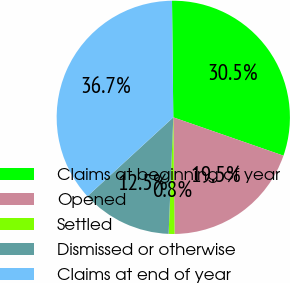Convert chart. <chart><loc_0><loc_0><loc_500><loc_500><pie_chart><fcel>Claims at beginning of year<fcel>Opened<fcel>Settled<fcel>Dismissed or otherwise<fcel>Claims at end of year<nl><fcel>30.5%<fcel>19.5%<fcel>0.81%<fcel>12.54%<fcel>36.65%<nl></chart> 